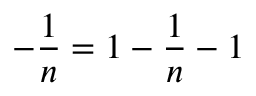Convert formula to latex. <formula><loc_0><loc_0><loc_500><loc_500>- \frac { 1 } { n } = 1 - \frac { 1 } { n } - 1</formula> 